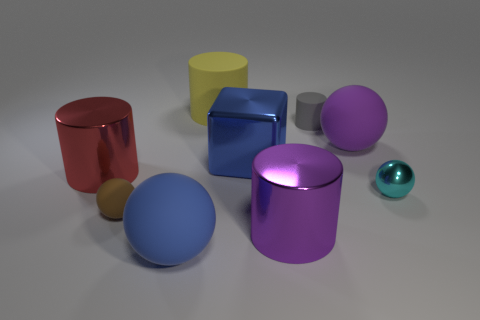Subtract all metallic balls. How many balls are left? 3 Subtract 2 spheres. How many spheres are left? 2 Subtract all purple spheres. How many spheres are left? 3 Subtract all balls. How many objects are left? 5 Add 6 big blue matte things. How many big blue matte things are left? 7 Add 2 large cyan metal cubes. How many large cyan metal cubes exist? 2 Subtract 1 blue blocks. How many objects are left? 8 Subtract all gray spheres. Subtract all blue cylinders. How many spheres are left? 4 Subtract all large brown metal cubes. Subtract all large metal blocks. How many objects are left? 8 